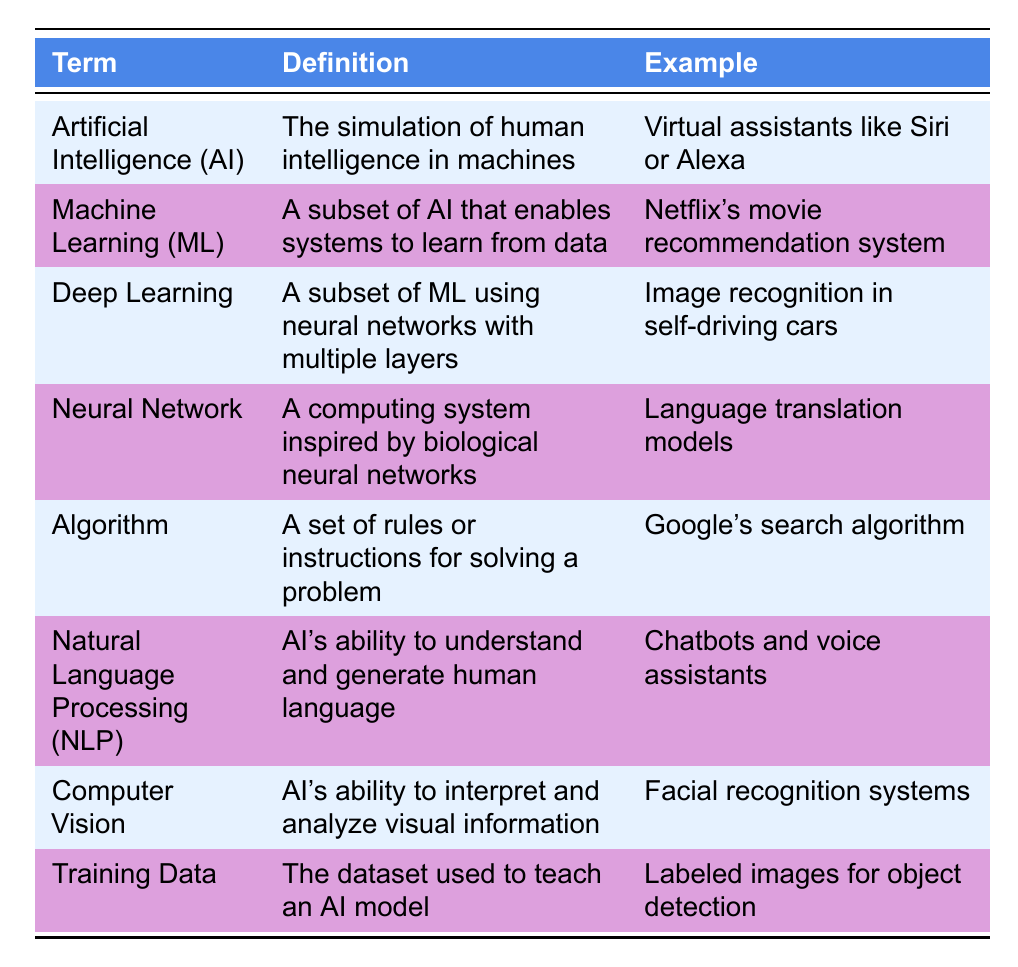What is the definition of Machine Learning? In the table, I find the row for Machine Learning which states that it is "A subset of AI that enables systems to learn from data."
Answer: A subset of AI that enables systems to learn from data Can you give an example of Natural Language Processing? Looking at the row for Natural Language Processing, it lists "Chatbots and voice assistants" as an example.
Answer: Chatbots and voice assistants Is Deep Learning a subset of AI? Deep Learning is classified as a subset of Machine Learning, which is itself a subset of AI. Therefore, it is true that Deep Learning is a subset of AI.
Answer: Yes Which term has an example related to self-driving cars? I check the examples given in the table. The row for Deep Learning mentions "Image recognition in self-driving cars."
Answer: Deep Learning How many terms related to AI are mentioned in the table? Counting the rows in the table, there are eight terms listed related to AI terminology.
Answer: Eight What is the difference between an Algorithm and a Neural Network? An Algorithm is described as "A set of rules or instructions for solving a problem," while a Neural Network is described as "A computing system inspired by biological neural networks." Hence, they serve different functions; one is a method, and the other is an architecture.
Answer: An Algorithm is a method, and a Neural Network is an architecture What type of data is used for training AI models? According to the table, the definition of Training Data states that it is "The dataset used to teach an AI model," directly indicating what kind of data it refers to.
Answer: The dataset used to teach an AI model Which terms are examples of applications in AI concerning understanding human language? By examining the examples in the table, both Natural Language Processing and Machine Learning share applications related to language understanding, with NLP specifically focusing on that ability through chatbots and voice assistants.
Answer: Natural Language Processing and Machine Learning What is the connection between Neural Networks and language translation models? The table indicates that Neural Networks are described as "A computing system inspired by biological neural networks," and it lists "Language translation models" as an example, which shows that Neural Networks can directly be applied to the task of language translation.
Answer: Neural Networks are used for language translation models 